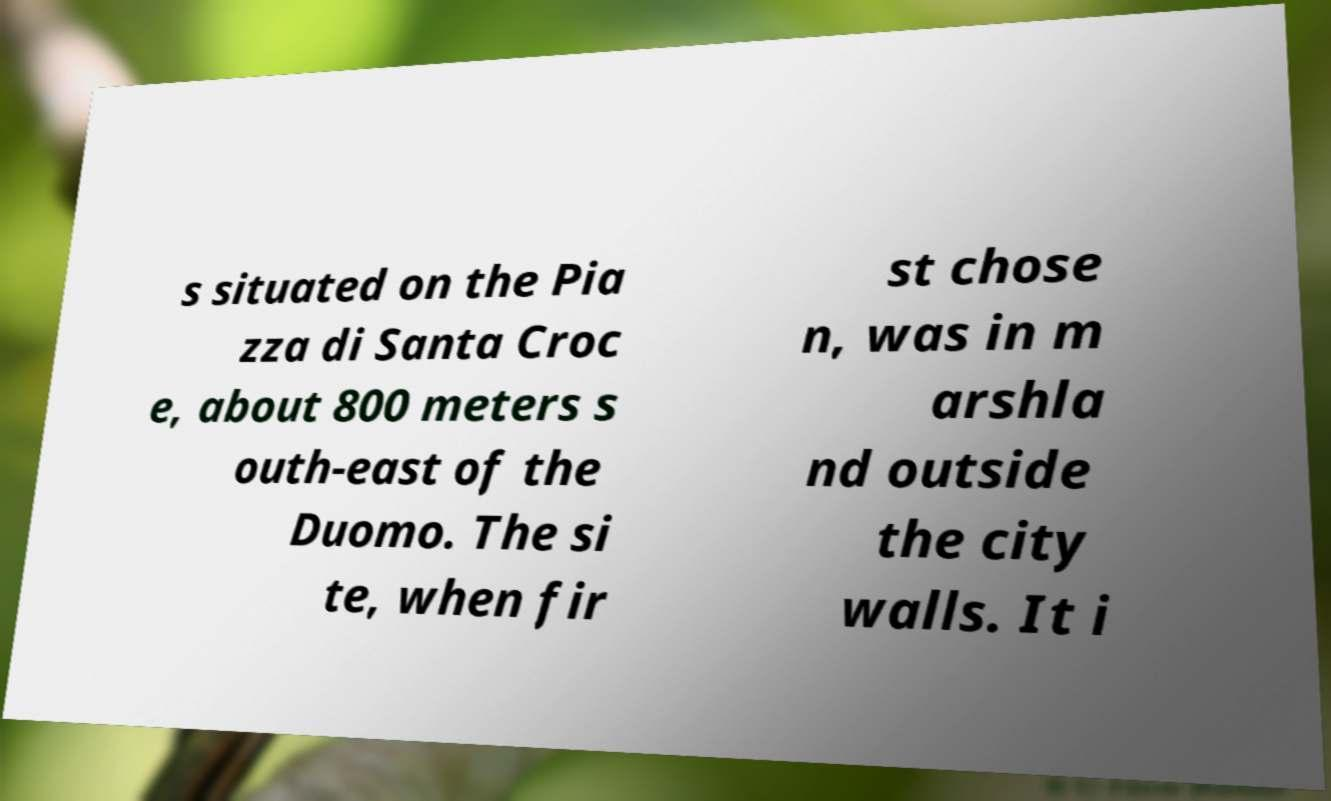For documentation purposes, I need the text within this image transcribed. Could you provide that? s situated on the Pia zza di Santa Croc e, about 800 meters s outh-east of the Duomo. The si te, when fir st chose n, was in m arshla nd outside the city walls. It i 